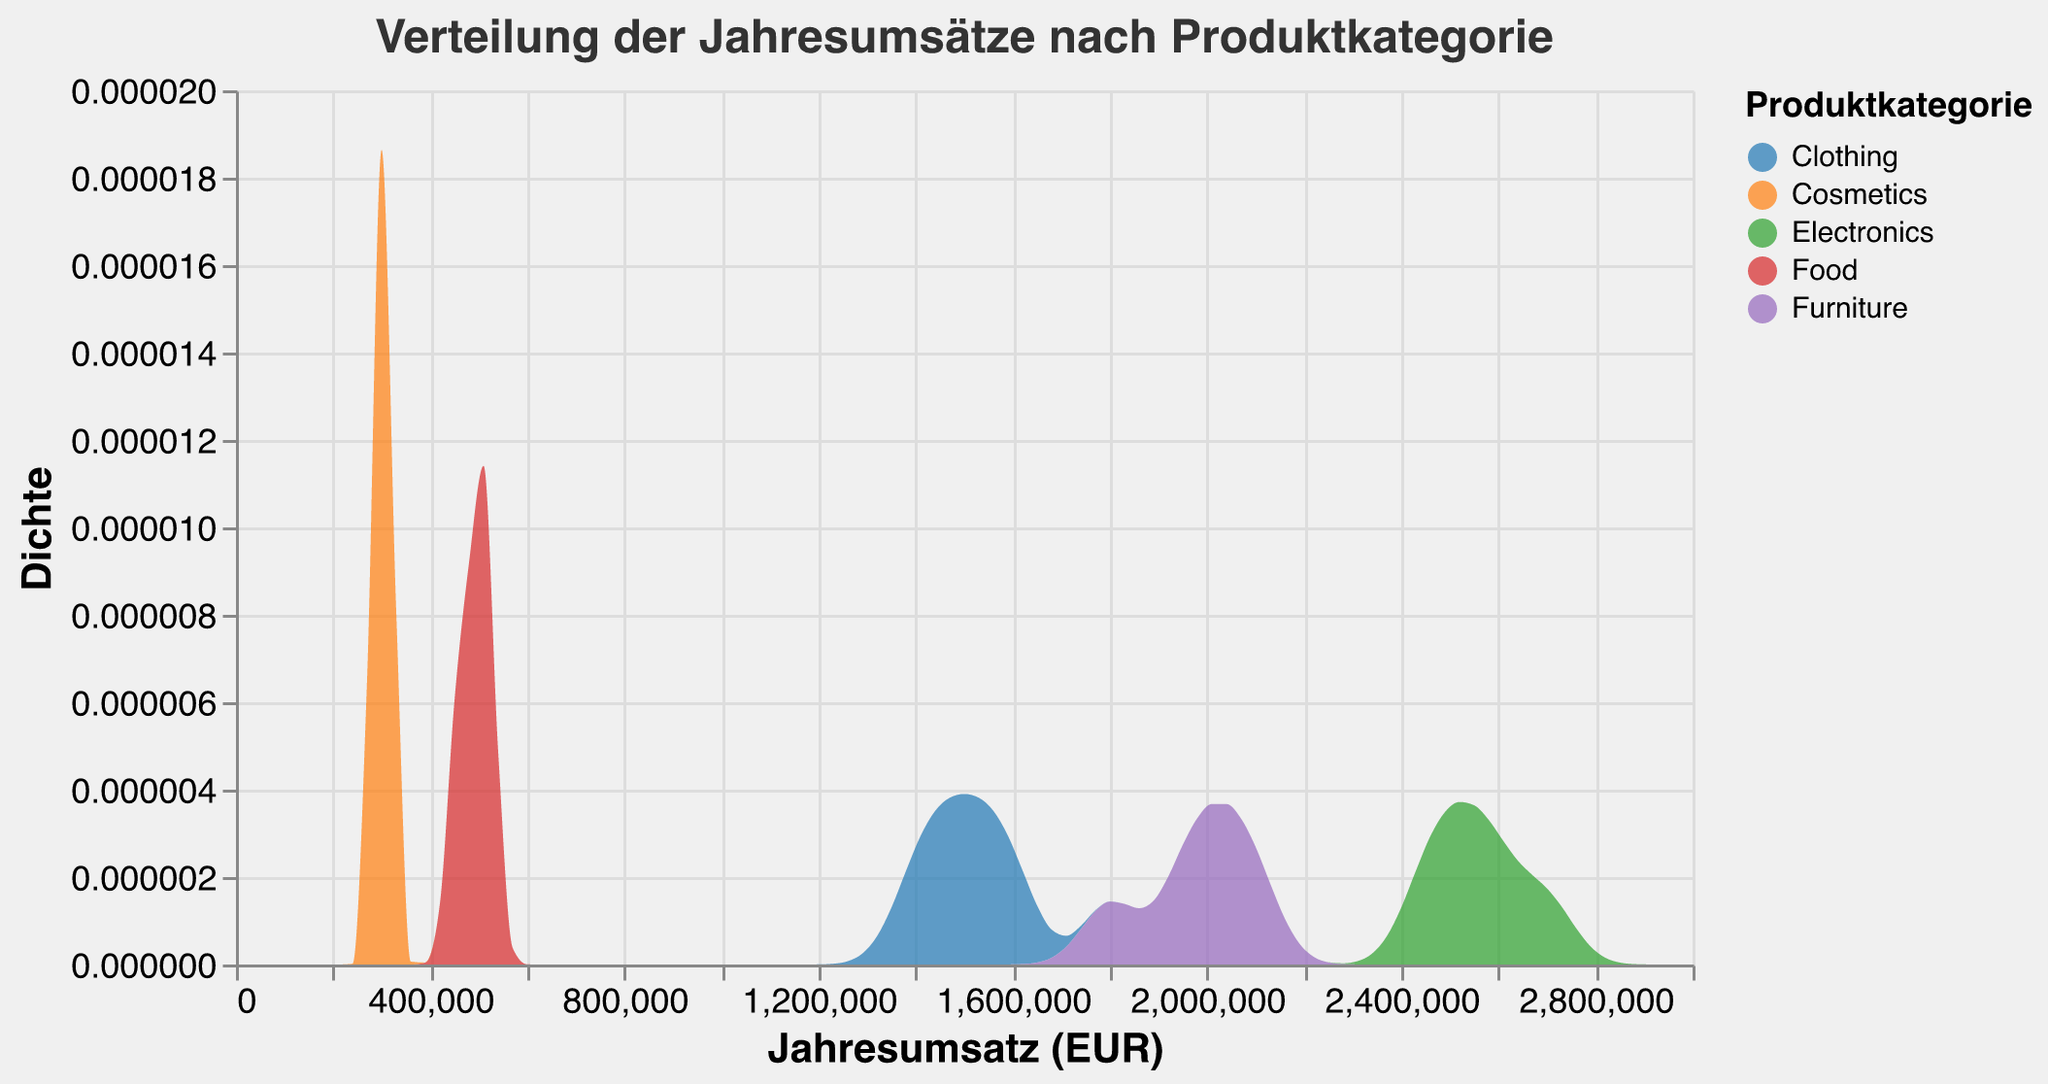What is the title of the figure? The title is usually located at the top of the figure and gives an overview of what the plot represents.
Answer: Verteilung der Jahresumsätze nach Produktkategorie What are the product categories represented in the figure? The legend of the figure shows the different product categories represented.
Answer: Electronics, Clothing, Food, Furniture, Cosmetics What is the range of the annual sales revenue shown on the x-axis? The x-axis (Jahresumsatz (EUR)) shows the range of annual sales revenue values.
Answer: 0 to 3,000,000 EUR Which product category has the lowest range of annual sales revenue? By observing the peaks and spread of the densities on the x-axis, the category with the smallest spread can be identified.
Answer: Cosmetics Which product category has the highest peak density? Look for the highest peak along the y-axis (Dichte) and see which product category it corresponds to.
Answer: Electronics Compare the annual sales revenue range for Electronics and Furniture. Which one is broader? Check the width of the density distribution for both Electronics and Furniture categories on the x-axis.
Answer: Electronics What is the approximate average annual sales revenue for the Clothing category? Find the center of the Clothing distribution on the x-axis and estimate the middle value.
Answer: 1,500,000 EUR Which product category appears to have the smallest average annual sales revenue? Look for the product category with its central distribution around the lowest x-axis values.
Answer: Cosmetics How does the density distribution for Food compare to that of Clothing? Observe the spread and peak of the distributions for Food and Clothing to see which is wider and higher.
Answer: Food has a lower peak and narrower spread compared to Clothing 